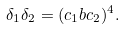<formula> <loc_0><loc_0><loc_500><loc_500>\delta _ { 1 } \delta _ { 2 } = ( c _ { 1 } b c _ { 2 } ) ^ { 4 } .</formula> 